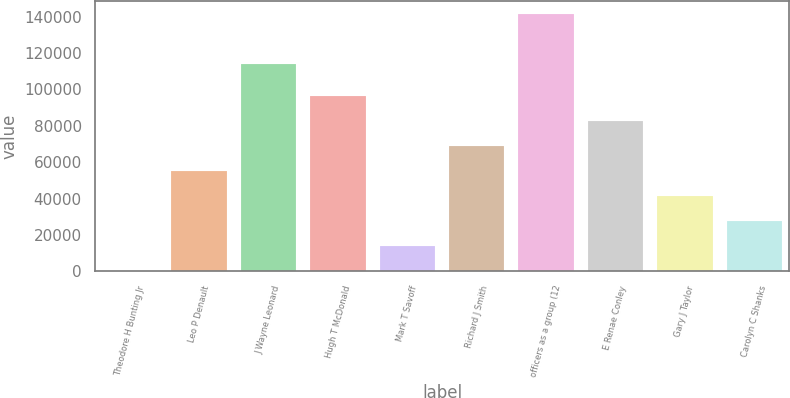<chart> <loc_0><loc_0><loc_500><loc_500><bar_chart><fcel>Theodore H Bunting Jr<fcel>Leo P Denault<fcel>J Wayne Leonard<fcel>Hugh T McDonald<fcel>Mark T Savoff<fcel>Richard J Smith<fcel>officers as a group (12<fcel>E Renae Conley<fcel>Gary J Taylor<fcel>Carolyn C Shanks<nl><fcel>128<fcel>55115.6<fcel>113977<fcel>96356.3<fcel>13874.9<fcel>68862.5<fcel>141471<fcel>82609.4<fcel>41368.7<fcel>27621.8<nl></chart> 